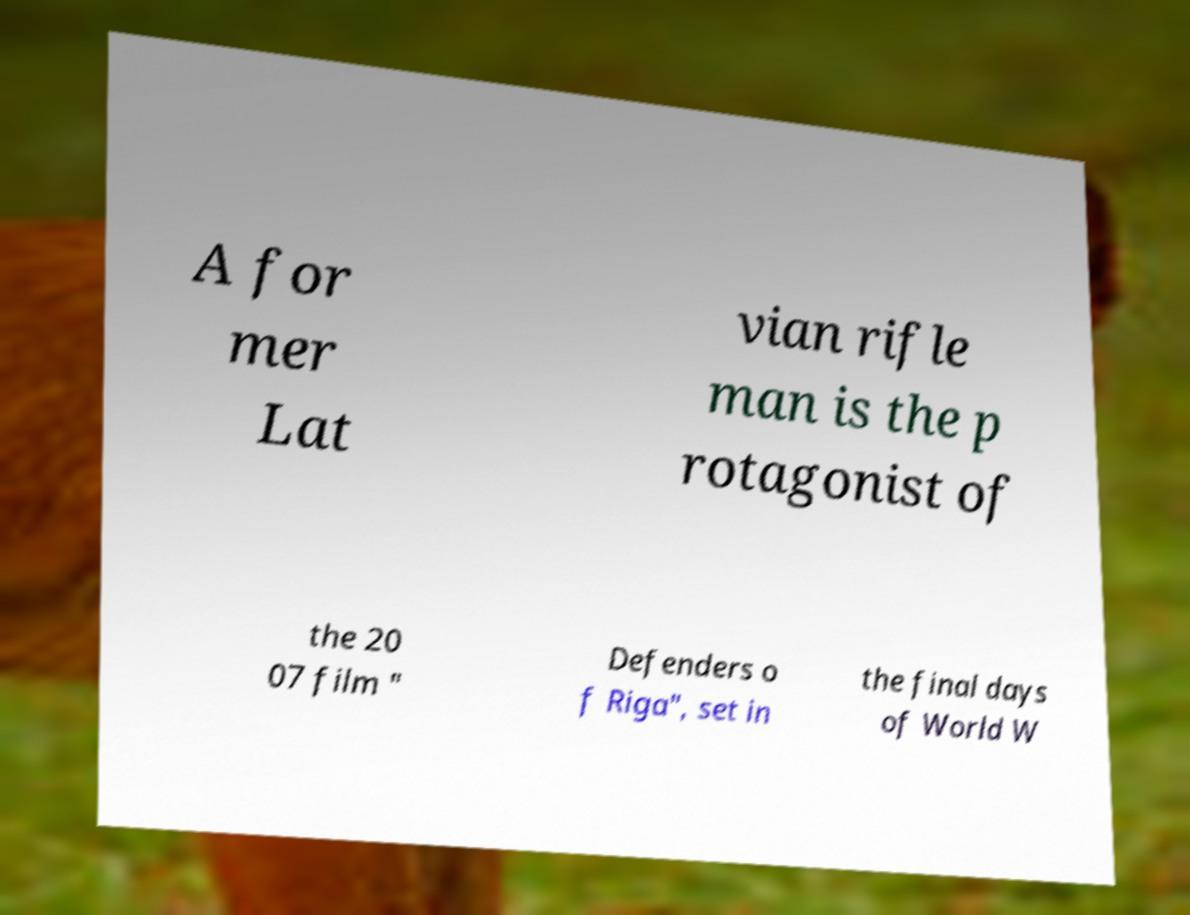There's text embedded in this image that I need extracted. Can you transcribe it verbatim? A for mer Lat vian rifle man is the p rotagonist of the 20 07 film " Defenders o f Riga", set in the final days of World W 